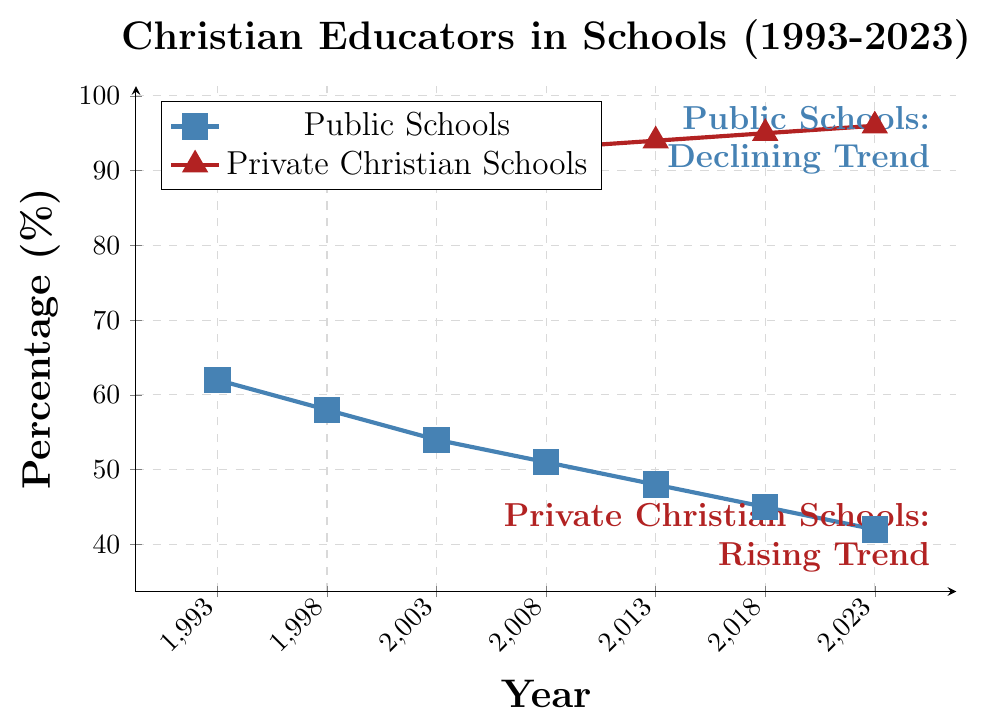What's the trend in the percentage of Christian educators in public schools over the last 30 years? The percentage of Christian educators in public schools has shown a consistent declining trend. Starting from 62% in 1993, it has progressively decreased to 42% by 2023.
Answer: Declining What's the difference in the percentage of Christian educators between public and private Christian schools in 2023? In 2023, the percentage for public schools is 42%, while for private Christian schools it is 96%. The difference is calculated as 96 - 42.
Answer: 54% Which year shows the smallest gap between the percentage of Christian educators in public and private Christian schools and what is the gap? To find the smallest gap, compute the difference for each year (1993: 27%, 1998: 33%, 2003: 38%, 2008: 42%, 2013: 46%, 2018: 50%, 2023: 54%). The smallest gap is in 1993 (89% - 62% = 27%).
Answer: 1993, 27% What can be said about the visual trend of the lines representing public and private Christian schools? The line for public schools (blue with square markers) shows a decreasing trend over time, while the line for private Christian schools (red with triangle markers) shows an increasing trend.
Answer: Decreasing for public, increasing for private By how many percentage points did the percentage of Christian educators in private Christian schools increase from 1993 to 2023? The percentage for private Christian schools in 1993 was 89%, and in 2023, it is 96%. Calculate the increase: 96 - 89.
Answer: 7% Which sector, public or private Christian schools, exhibited a steadier trend over the past 30 years? The trend for private Christian schools is steadier, showing a consistent upward slope, while public schools display a more variable decline.
Answer: Private Christian schools In what year did the percentage of Christian educators in public schools fall below 50%? Referring to the data, in 2013 the percentage of Christian educators in public schools was 48%, which is the first year it fell below 50%.
Answer: 2013 